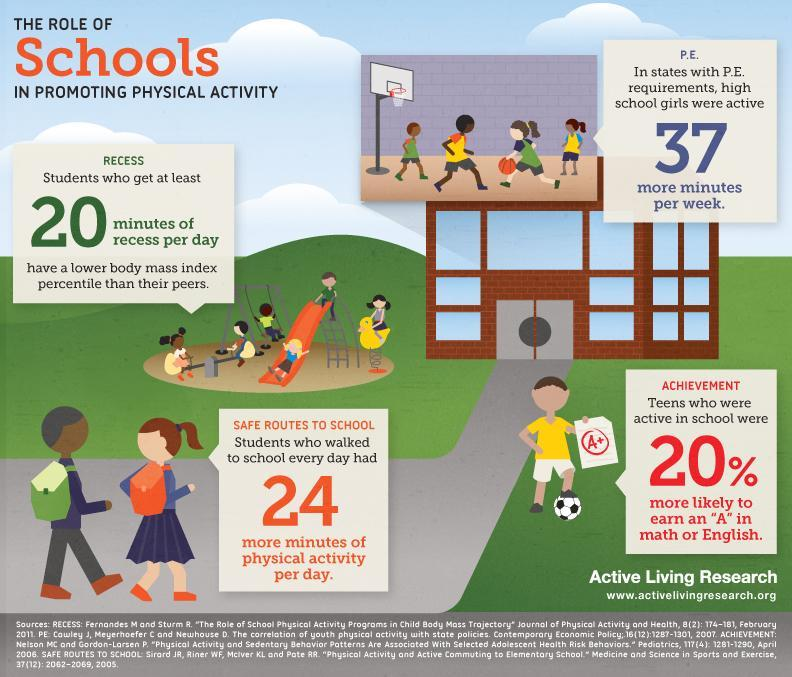Which states had more active high school girls?
Answer the question with a short phrase. states with P.E. requirements 